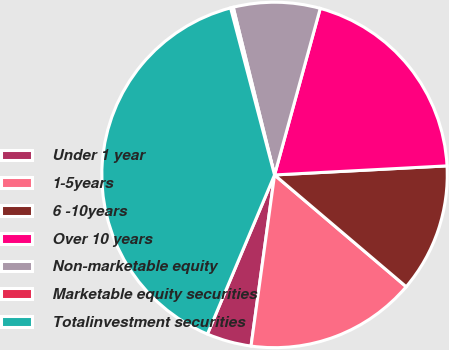Convert chart to OTSL. <chart><loc_0><loc_0><loc_500><loc_500><pie_chart><fcel>Under 1 year<fcel>1-5years<fcel>6 -10years<fcel>Over 10 years<fcel>Non-marketable equity<fcel>Marketable equity securities<fcel>Totalinvestment securities<nl><fcel>4.18%<fcel>15.97%<fcel>12.04%<fcel>19.9%<fcel>8.11%<fcel>0.25%<fcel>39.55%<nl></chart> 